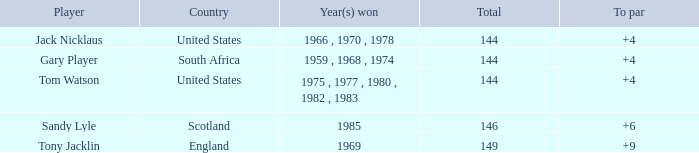What was Tom Watson's lowest To par when the total was larger than 144? None. 